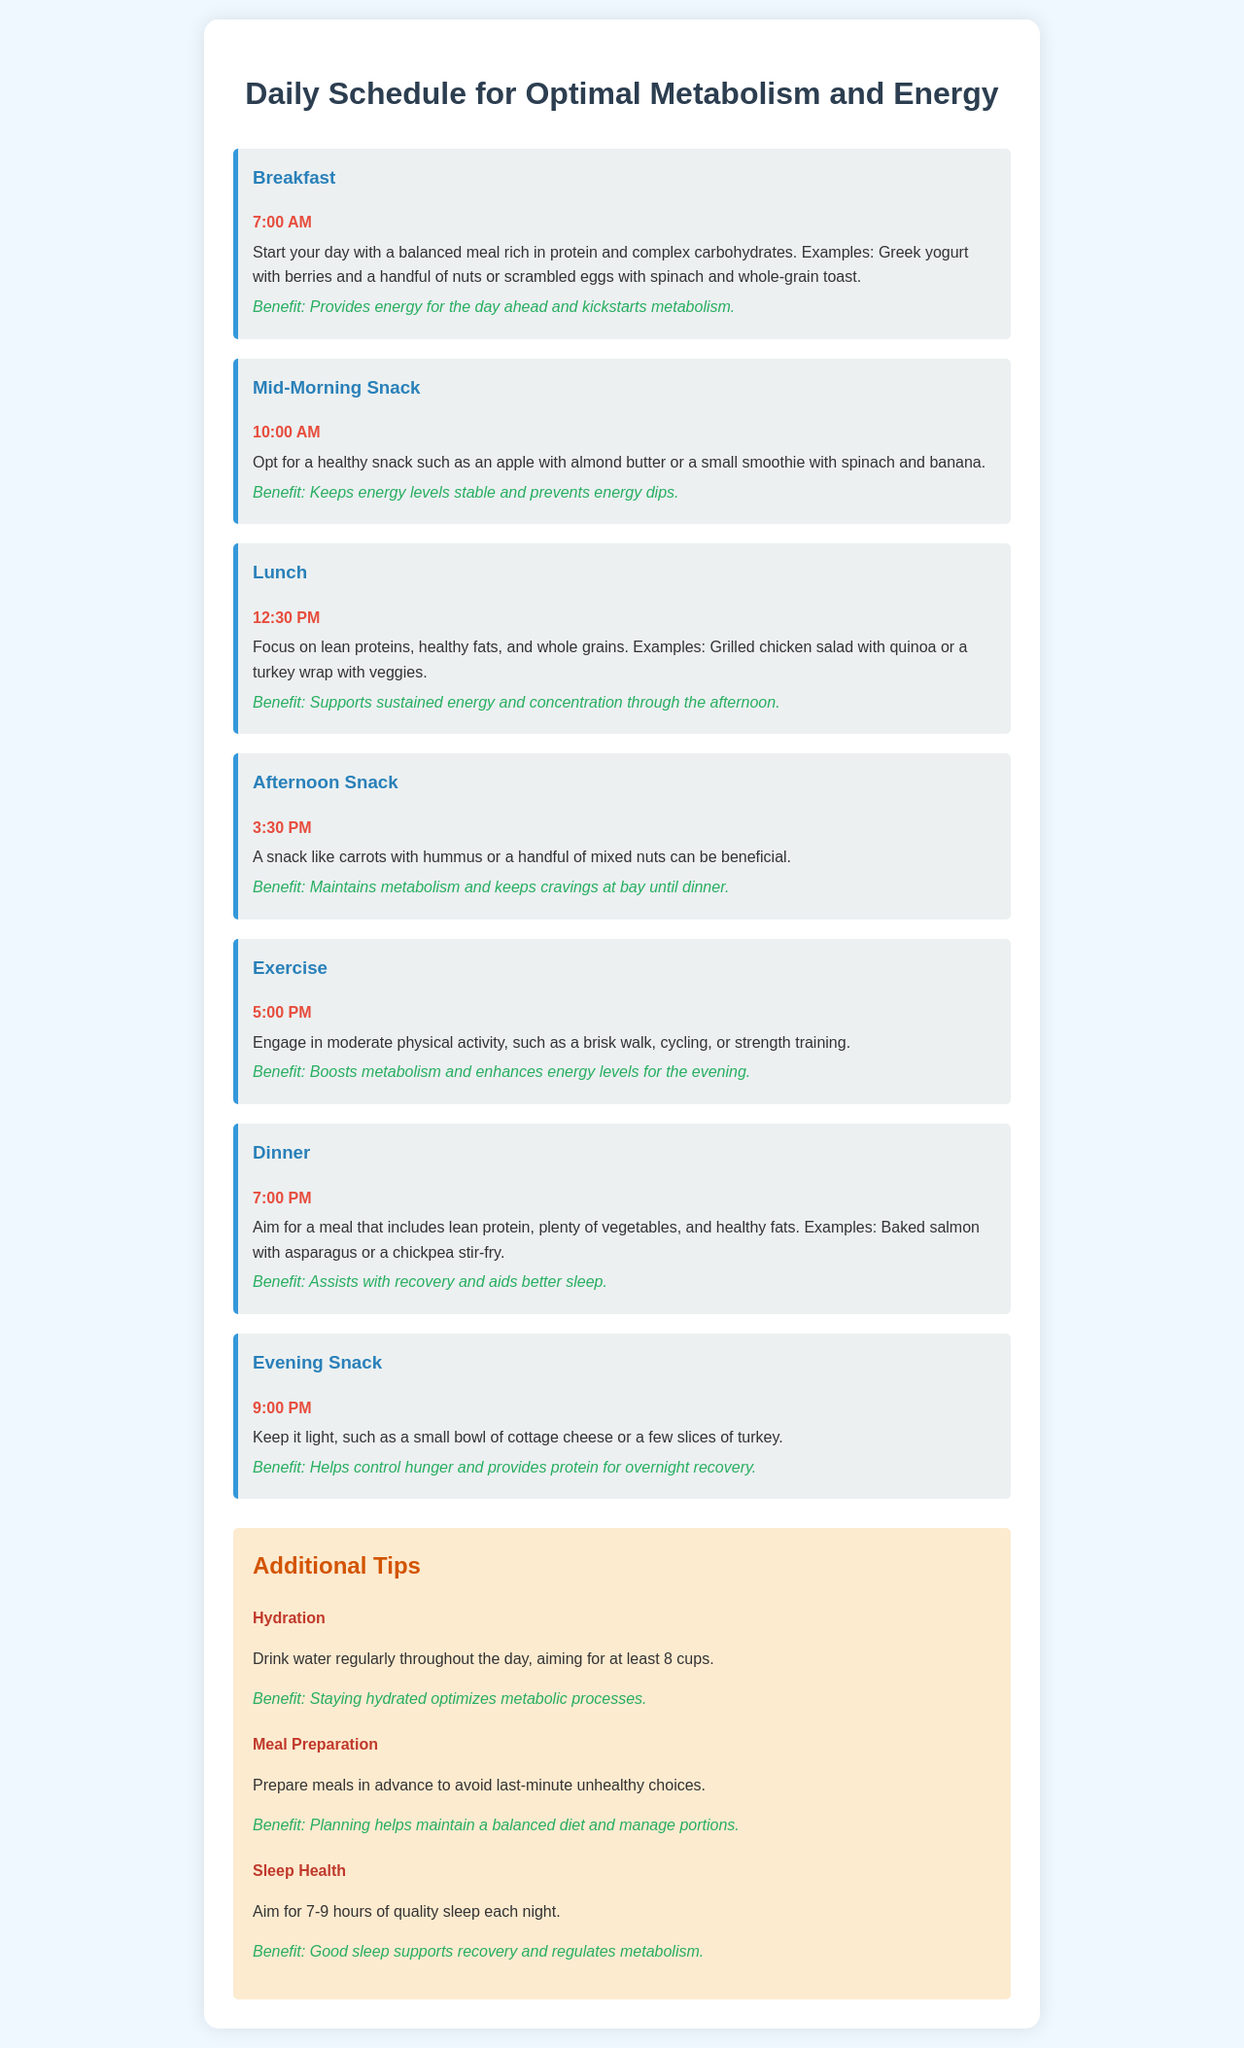What time is breakfast scheduled? The document states that breakfast is scheduled for 7:00 AM.
Answer: 7:00 AM What is a suggested morning snack? The document suggests an apple with almond butter or a small smoothie with spinach and banana as a morning snack.
Answer: Apple with almond butter What should lunch focus on? The document indicates that lunch should focus on lean proteins, healthy fats, and whole grains.
Answer: Lean proteins, healthy fats, and whole grains What exercise is recommended at 5:00 PM? The document recommends engaging in moderate physical activity, such as a brisk walk, cycling, or strength training at 5:00 PM.
Answer: Brisk walk, cycling, or strength training What benefit does breakfast provide? The document states that breakfast provides energy for the day ahead and kickstarts metabolism.
Answer: Energy for the day ahead How many cups of water should be consumed daily? The document mentions aiming for at least 8 cups of water daily.
Answer: At least 8 cups What time is dinner scheduled? The document states that dinner is scheduled for 7:00 PM.
Answer: 7:00 PM What type of meal is suggested for the evening snack? The document suggests keeping the evening snack light, such as a small bowl of cottage cheese or a few slices of turkey.
Answer: Small bowl of cottage cheese What is a key tip for meal preparation? The document advises preparing meals in advance to avoid last-minute unhealthy choices.
Answer: Prepare meals in advance 